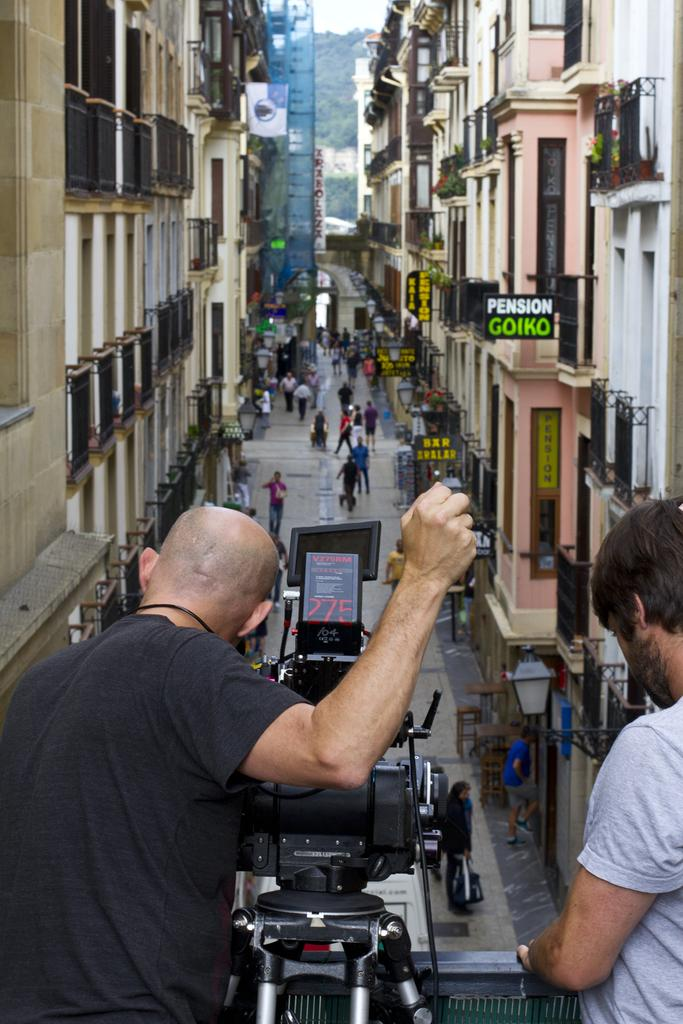What is the main subject of the image? There is a person in the image. What is the person wearing? The person is wearing a black T-shirt. What is the person holding in their hand? The person is holding a camera in their hand. What can be seen in the background of the image? There are persons walking and buildings in the background of the image. Can you tell me how many knives the person is holding in the image? There are no knives present in the image; the person is holding a camera. 